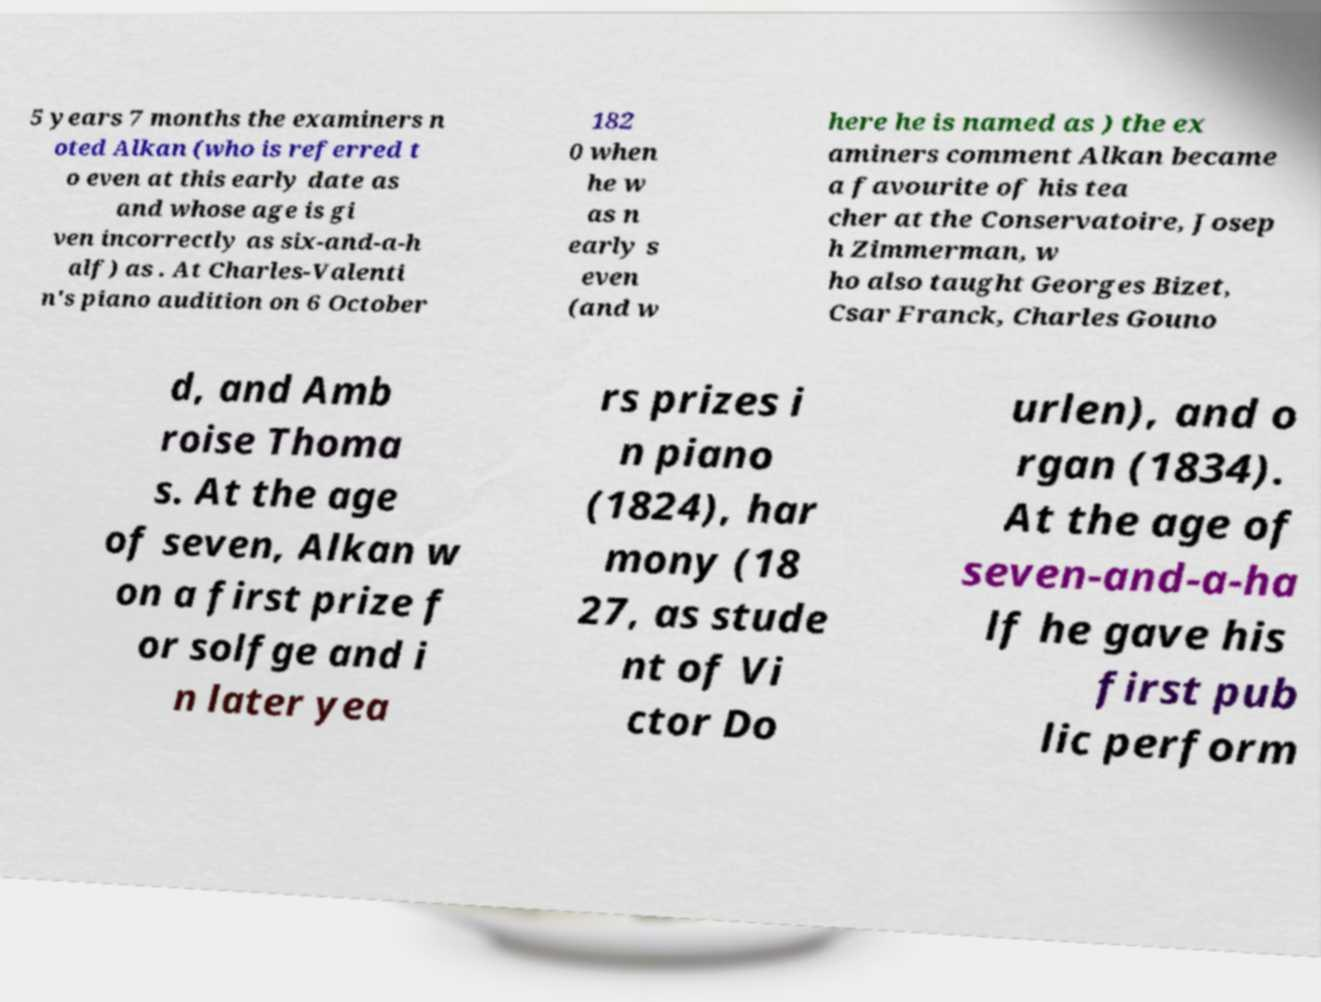Can you accurately transcribe the text from the provided image for me? 5 years 7 months the examiners n oted Alkan (who is referred t o even at this early date as and whose age is gi ven incorrectly as six-and-a-h alf) as . At Charles-Valenti n's piano audition on 6 October 182 0 when he w as n early s even (and w here he is named as ) the ex aminers comment Alkan became a favourite of his tea cher at the Conservatoire, Josep h Zimmerman, w ho also taught Georges Bizet, Csar Franck, Charles Gouno d, and Amb roise Thoma s. At the age of seven, Alkan w on a first prize f or solfge and i n later yea rs prizes i n piano (1824), har mony (18 27, as stude nt of Vi ctor Do urlen), and o rgan (1834). At the age of seven-and-a-ha lf he gave his first pub lic perform 